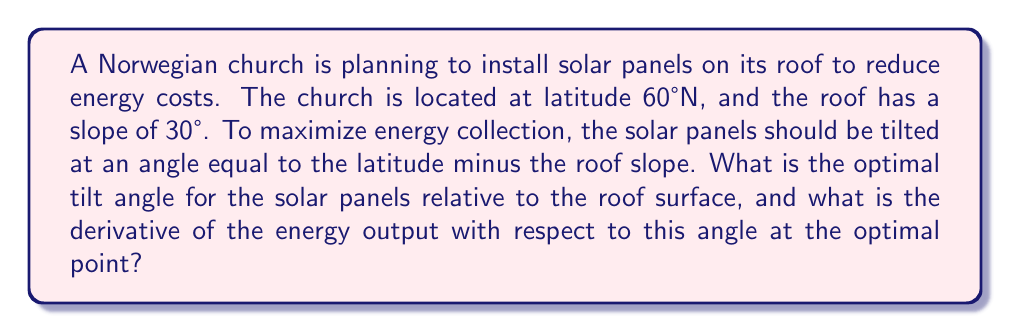Could you help me with this problem? Let's approach this step-by-step:

1) First, we calculate the optimal tilt angle for the solar panels:
   Optimal angle = Latitude - Roof slope
   $$ \theta_{optimal} = 60° - 30° = 30° $$

2) Now, let's consider the energy output as a function of the tilt angle. A simple model for this is:
   $$ E(\theta) = E_{max} \cdot \cos(\theta - \theta_{optimal}) $$
   Where $E_{max}$ is the maximum possible energy output.

3) To find the derivative of this function with respect to $\theta$, we use the chain rule:
   $$ \frac{dE}{d\theta} = -E_{max} \cdot \sin(\theta - \theta_{optimal}) $$

4) At the optimal angle, $\theta = \theta_{optimal}$, so:
   $$ \left.\frac{dE}{d\theta}\right|_{\theta=\theta_{optimal}} = -E_{max} \cdot \sin(0) = 0 $$

5) This confirms that the energy output is at a maximum at the optimal angle, as the derivative is zero.

[asy]
import geometry;

size(200);
draw((-2,0)--(2,0), arrow=Arrow);
draw((0,-0.5)--(0,2), arrow=Arrow);
draw((-1.5,0)--(-0.5,1.732), arrow=Arrow);
label("$\theta$", (-0.8,0.5), E);
label("Energy Output", (0,2.2), N);
label("Tilt Angle", (2.2,0), E);
[/asy]
Answer: $30°$; $0$ 